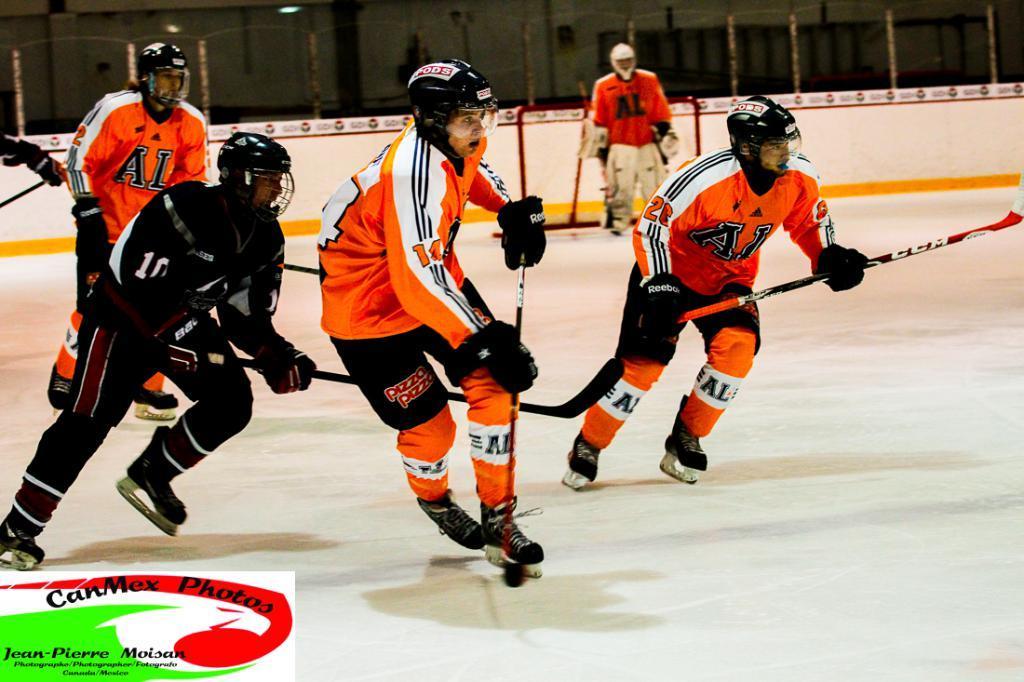In one or two sentences, can you explain what this image depicts? In this picture I can see group of people playing a ice hockey game with the hockey sticks on the ice, and in the background there is a hockey net , iron rods, and there is a watermark on the image. 